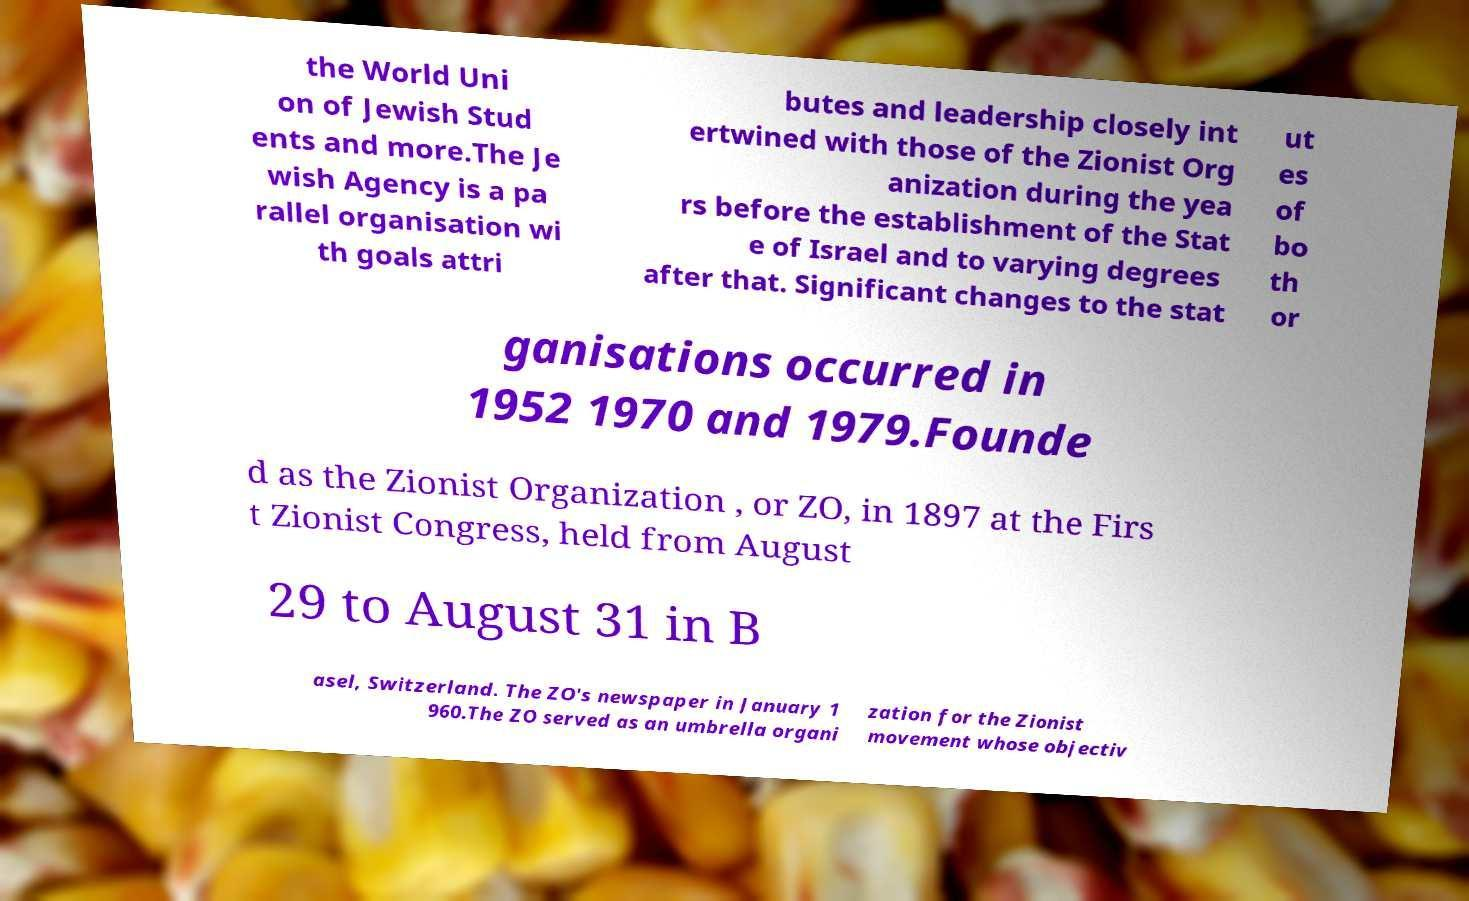Could you assist in decoding the text presented in this image and type it out clearly? the World Uni on of Jewish Stud ents and more.The Je wish Agency is a pa rallel organisation wi th goals attri butes and leadership closely int ertwined with those of the Zionist Org anization during the yea rs before the establishment of the Stat e of Israel and to varying degrees after that. Significant changes to the stat ut es of bo th or ganisations occurred in 1952 1970 and 1979.Founde d as the Zionist Organization , or ZO, in 1897 at the Firs t Zionist Congress, held from August 29 to August 31 in B asel, Switzerland. The ZO's newspaper in January 1 960.The ZO served as an umbrella organi zation for the Zionist movement whose objectiv 